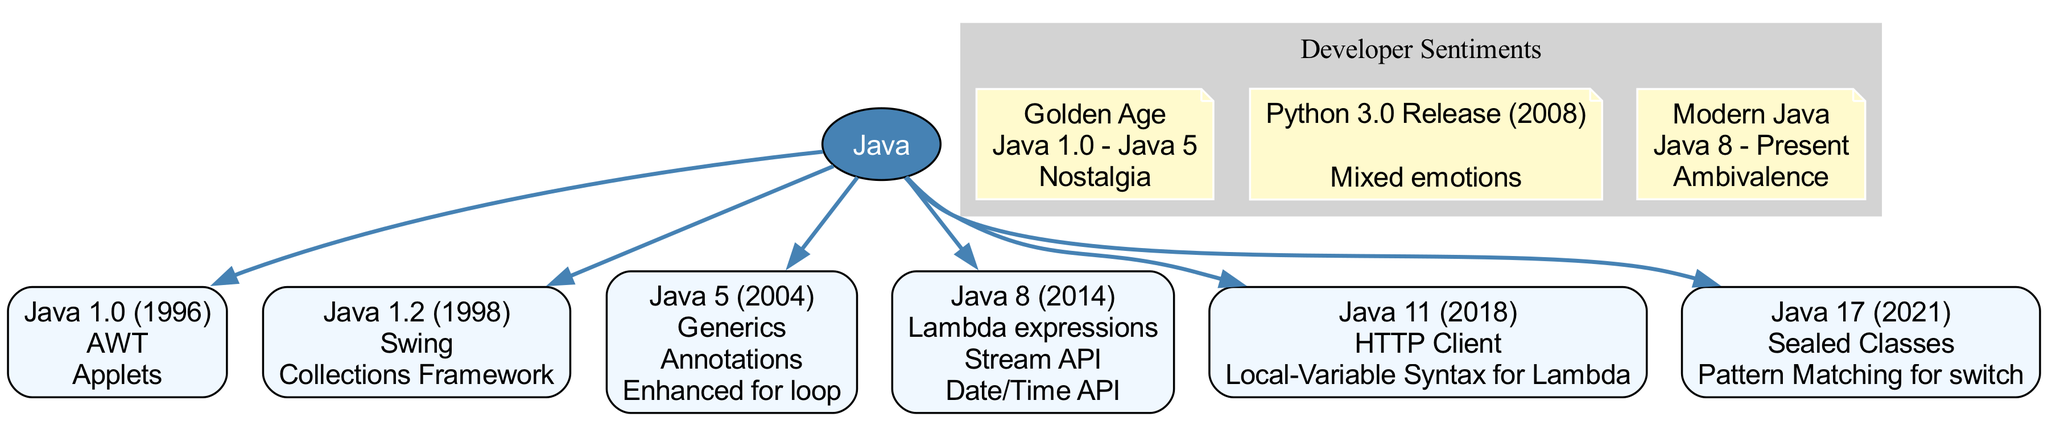What is the first version of Java mentioned in the diagram? The diagram lists the versions of Java starting from Java 1.0. It is clearly labeled as the first child of the root node "Java."
Answer: Java 1.0 (1996) Which feature is introduced in Java 8? Looking at the child nodes under "Java," Java 8 (2014) has features listed. One of those features is "Lambda expressions."
Answer: Lambda expressions How many major versions of Java are shown in the diagram? The diagram lists six major versions of Java from Java 1.0 to Java 17. By counting the children of the root node, we find that there are six nodes.
Answer: 6 What sentiment is associated with the era "Modern Java"? The diagram includes a sentiment section with various eras. The "Modern Java" era is specifically noted to have the feeling "Ambivalence."
Answer: Ambivalence Which version introduced the Collections Framework? The diagram provides features under the Java 1.2 node, where it specifically mentions the "Collections Framework" as a feature.
Answer: Java 1.2 (1998) What is the range of years for the "Golden Age" sentiment? The sentiment under "Golden Age" includes a range of years specified as "Java 1.0 - Java 5." This can be identified in the sentiment section of the diagram.
Answer: Java 1.0 - Java 5 Which version is noted for adding Sealed Classes? Reviewing the features listed under child nodes, Sealed Classes are introduced in Java 17 (2021), as noted in its features.
Answer: Java 17 (2021) What is a feature introduced in Java 5? In the child node labeled Java 5 (2004), there are multiple features listed, including "Generics." This indicates Generics is a significant feature for that version.
Answer: Generics What is the last version of Java mentioned? The last child node according to the sequence represents Java 17 (2021). By locating the last node in the diagram, we confirm this is the most recent version listed.
Answer: Java 17 (2021) 